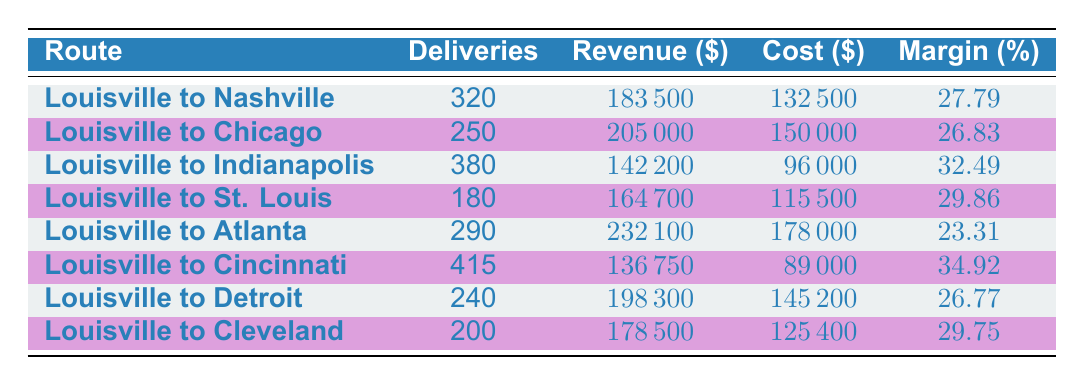What is the total revenue generated from all routes? To find the total revenue, we add the revenue from each route. The revenues are: 183500 + 205000 + 142200 + 164700 + 232100 + 136750 + 198300 + 178500. Summing these gives a total revenue of 1302050.
Answer: 1302050 Which route has the highest profit margin? Looking through the profit margins for each route, we see that the highest is 34.92%, which belongs to the route from Louisville to Cincinnati.
Answer: Louisville to Cincinnati What is the profit margin for the Louisville to Chicago route? The table shows that the profit margin for the Louisville to Chicago route is 26.83%.
Answer: 26.83 Are there more deliveries made to Indianapolis than to St. Louis? By comparing the total deliveries, Indianapolis has 380 while St. Louis has 180. Since 380 is greater than 180, the statement is true.
Answer: Yes What is the average profit margin across all routes? To find the average profit margin, we add all profit margins: 27.79 + 26.83 + 32.49 + 29.86 + 23.31 + 34.92 + 26.77 + 29.75 =  229.92. Dividing this sum by the number of routes, which is 8, gives an average profit margin of 28.74: 229.92 / 8 = 28.74.
Answer: 28.74 Is the total cost of deliveries to Atlanta greater than the total cost of deliveries to Nashville? The total cost for Atlanta is 178000, and for Nashville, it is 132500. Since 178000 is greater than 132500, the answer is yes.
Answer: Yes How much more total revenue does the Chicago route generate compared to the Indianapolis route? Chicago's total revenue is 205000 and Indianapolis's is 142200. To find the difference, we calculate 205000 - 142200 = 62800.
Answer: 62800 Which route has the lowest total revenue? By examining the total revenues, the lowest value is 136750, which corresponds to the Louisville to Cincinnati route.
Answer: Louisville to Cincinnati 